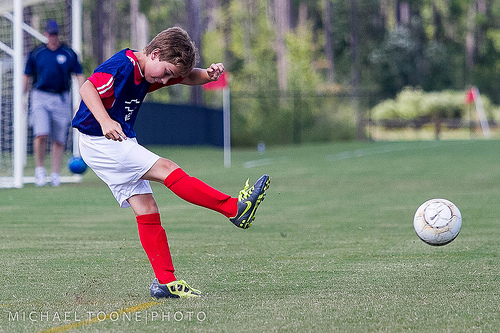<image>
Can you confirm if the boy is in front of the ball? No. The boy is not in front of the ball. The spatial positioning shows a different relationship between these objects. 